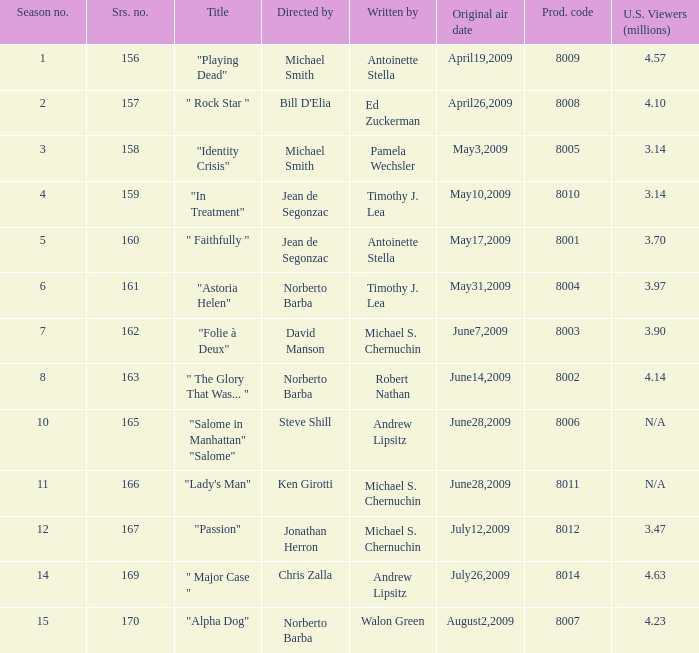What is the name of the episode whose writer is timothy j. lea and the director is norberto barba? "Astoria Helen". 